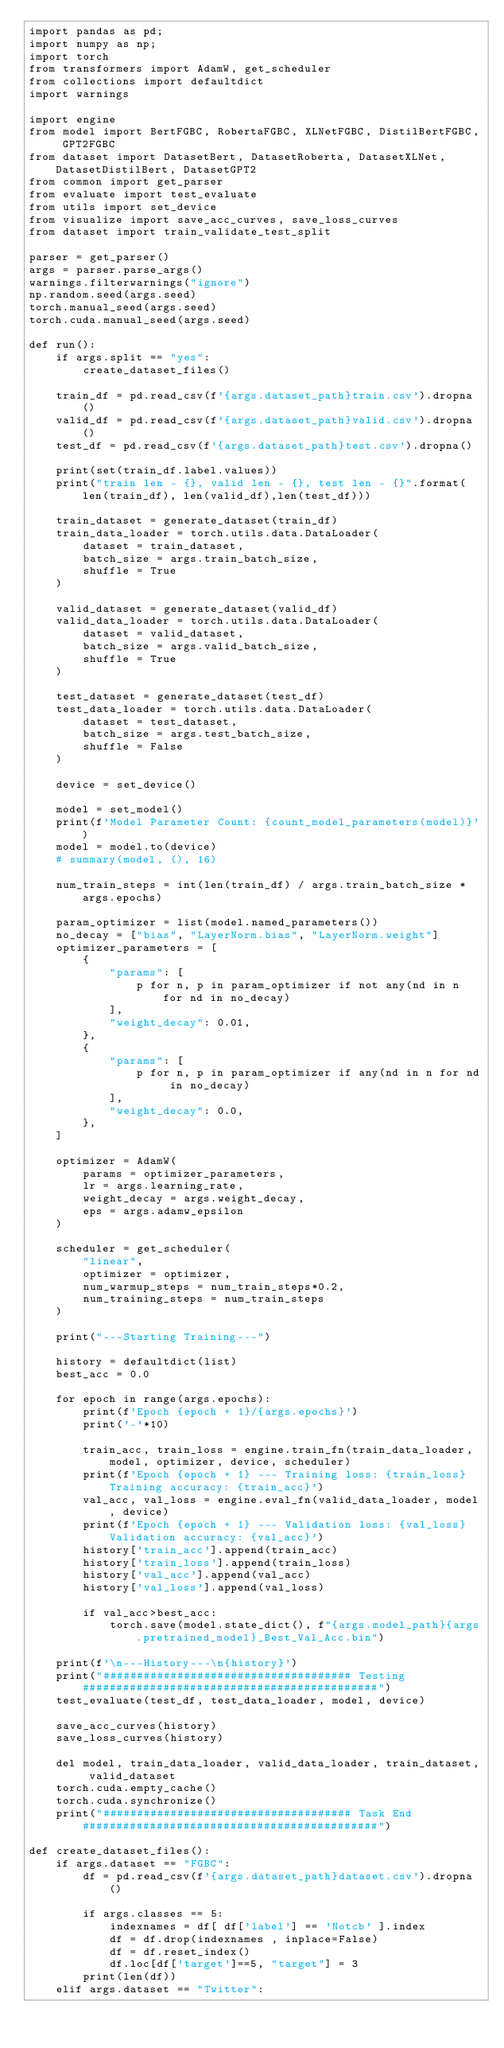<code> <loc_0><loc_0><loc_500><loc_500><_Python_>import pandas as pd;
import numpy as np;
import torch
from transformers import AdamW, get_scheduler
from collections import defaultdict
import warnings

import engine
from model import BertFGBC, RobertaFGBC, XLNetFGBC, DistilBertFGBC, GPT2FGBC
from dataset import DatasetBert, DatasetRoberta, DatasetXLNet, DatasetDistilBert, DatasetGPT2
from common import get_parser
from evaluate import test_evaluate
from utils import set_device
from visualize import save_acc_curves, save_loss_curves
from dataset import train_validate_test_split

parser = get_parser()
args = parser.parse_args()
warnings.filterwarnings("ignore")
np.random.seed(args.seed)
torch.manual_seed(args.seed)
torch.cuda.manual_seed(args.seed)

def run():
    if args.split == "yes":
        create_dataset_files()

    train_df = pd.read_csv(f'{args.dataset_path}train.csv').dropna()
    valid_df = pd.read_csv(f'{args.dataset_path}valid.csv').dropna()
    test_df = pd.read_csv(f'{args.dataset_path}test.csv').dropna()

    print(set(train_df.label.values))
    print("train len - {}, valid len - {}, test len - {}".format(len(train_df), len(valid_df),len(test_df)))

    train_dataset = generate_dataset(train_df)
    train_data_loader = torch.utils.data.DataLoader(
        dataset = train_dataset,
        batch_size = args.train_batch_size,
        shuffle = True
    )

    valid_dataset = generate_dataset(valid_df)
    valid_data_loader = torch.utils.data.DataLoader(
        dataset = valid_dataset,
        batch_size = args.valid_batch_size,
        shuffle = True
    )

    test_dataset = generate_dataset(test_df)
    test_data_loader = torch.utils.data.DataLoader(
        dataset = test_dataset,
        batch_size = args.test_batch_size,
        shuffle = False
    )
    
    device = set_device()

    model = set_model()
    print(f'Model Parameter Count: {count_model_parameters(model)}')
    model = model.to(device)
    # summary(model, (), 16)

    num_train_steps = int(len(train_df) / args.train_batch_size * args.epochs)

    param_optimizer = list(model.named_parameters())
    no_decay = ["bias", "LayerNorm.bias", "LayerNorm.weight"]
    optimizer_parameters = [
        {
            "params": [
                p for n, p in param_optimizer if not any(nd in n for nd in no_decay)
            ],
            "weight_decay": 0.01,
        },
        {
            "params": [
                p for n, p in param_optimizer if any(nd in n for nd in no_decay)
            ],
            "weight_decay": 0.0,
        },
    ]
    
    optimizer = AdamW(
        params = optimizer_parameters,
        lr = args.learning_rate,
        weight_decay = args.weight_decay,
        eps = args.adamw_epsilon
    )

    scheduler = get_scheduler(
        "linear",
        optimizer = optimizer,
        num_warmup_steps = num_train_steps*0.2,
        num_training_steps = num_train_steps
    )

    print("---Starting Training---")

    history = defaultdict(list)
    best_acc = 0.0
    
    for epoch in range(args.epochs):
        print(f'Epoch {epoch + 1}/{args.epochs}')
        print('-'*10)

        train_acc, train_loss = engine.train_fn(train_data_loader, model, optimizer, device, scheduler)
        print(f'Epoch {epoch + 1} --- Training loss: {train_loss} Training accuracy: {train_acc}')
        val_acc, val_loss = engine.eval_fn(valid_data_loader, model, device)
        print(f'Epoch {epoch + 1} --- Validation loss: {val_loss} Validation accuracy: {val_acc}')
        history['train_acc'].append(train_acc)
        history['train_loss'].append(train_loss)
        history['val_acc'].append(val_acc)
        history['val_loss'].append(val_loss)

        if val_acc>best_acc:
            torch.save(model.state_dict(), f"{args.model_path}{args.pretrained_model}_Best_Val_Acc.bin")

    print(f'\n---History---\n{history}')
    print("##################################### Testing ############################################")
    test_evaluate(test_df, test_data_loader, model, device)

    save_acc_curves(history)
    save_loss_curves(history)
    
    del model, train_data_loader, valid_data_loader, train_dataset, valid_dataset
    torch.cuda.empty_cache()
    torch.cuda.synchronize()
    print("##################################### Task End ############################################")

def create_dataset_files():
    if args.dataset == "FGBC":
        df = pd.read_csv(f'{args.dataset_path}dataset.csv').dropna()

        if args.classes == 5:
            indexnames = df[ df['label'] == 'Notcb' ].index
            df = df.drop(indexnames , inplace=False)
            df = df.reset_index()
            df.loc[df['target']==5, "target"] = 3
        print(len(df))
    elif args.dataset == "Twitter":</code> 